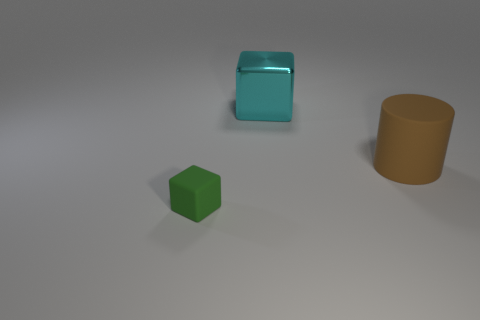How many things are either things behind the brown cylinder or matte things on the left side of the cyan shiny cube? There is one green matte cube on the left side of the cyan shiny cube. There are no items behind the brown cylinder when viewing from the current perspective. Therefore, the total count of items that fit the description is one. 